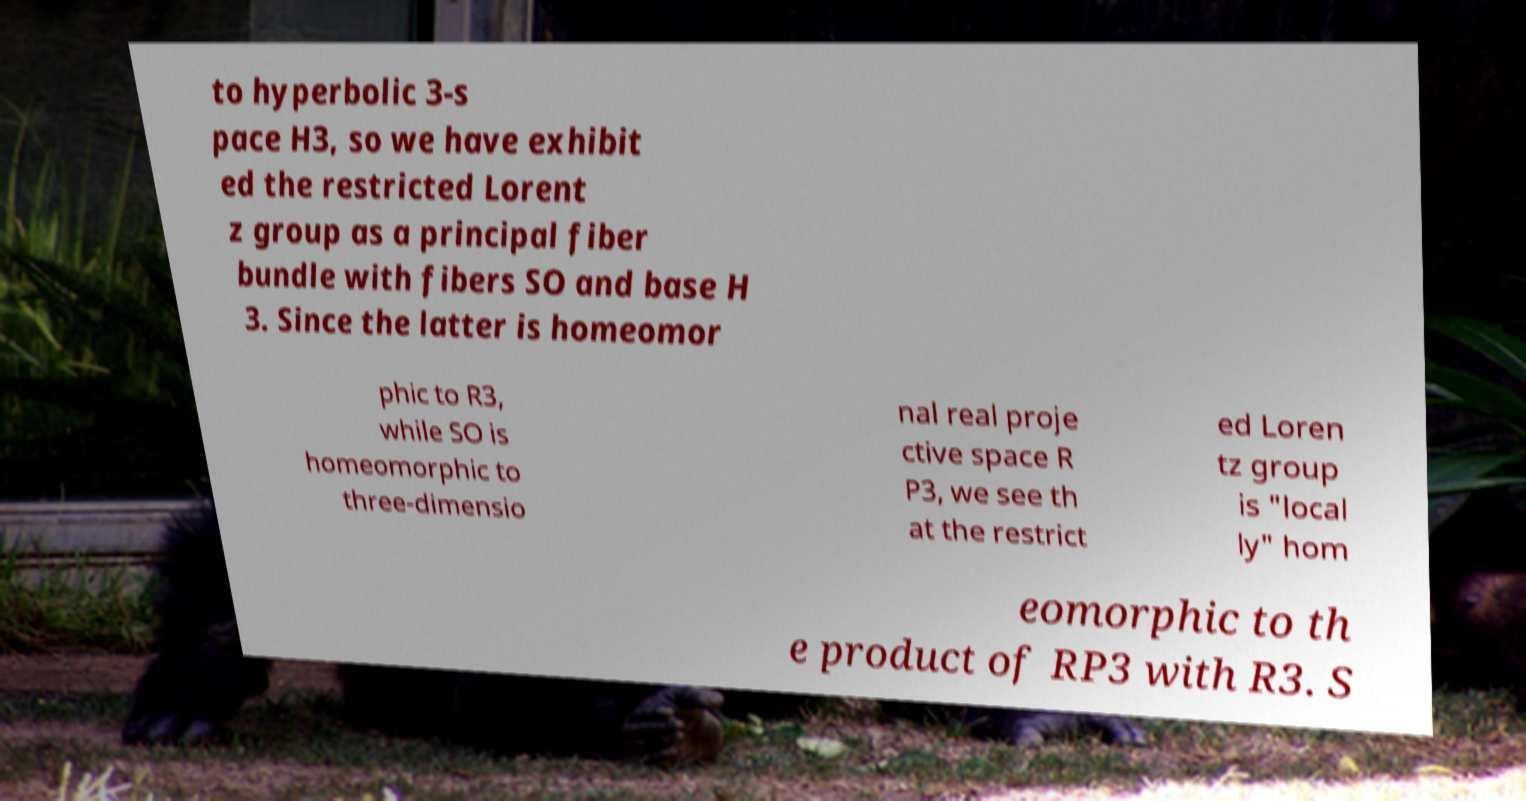Could you assist in decoding the text presented in this image and type it out clearly? to hyperbolic 3-s pace H3, so we have exhibit ed the restricted Lorent z group as a principal fiber bundle with fibers SO and base H 3. Since the latter is homeomor phic to R3, while SO is homeomorphic to three-dimensio nal real proje ctive space R P3, we see th at the restrict ed Loren tz group is "local ly" hom eomorphic to th e product of RP3 with R3. S 